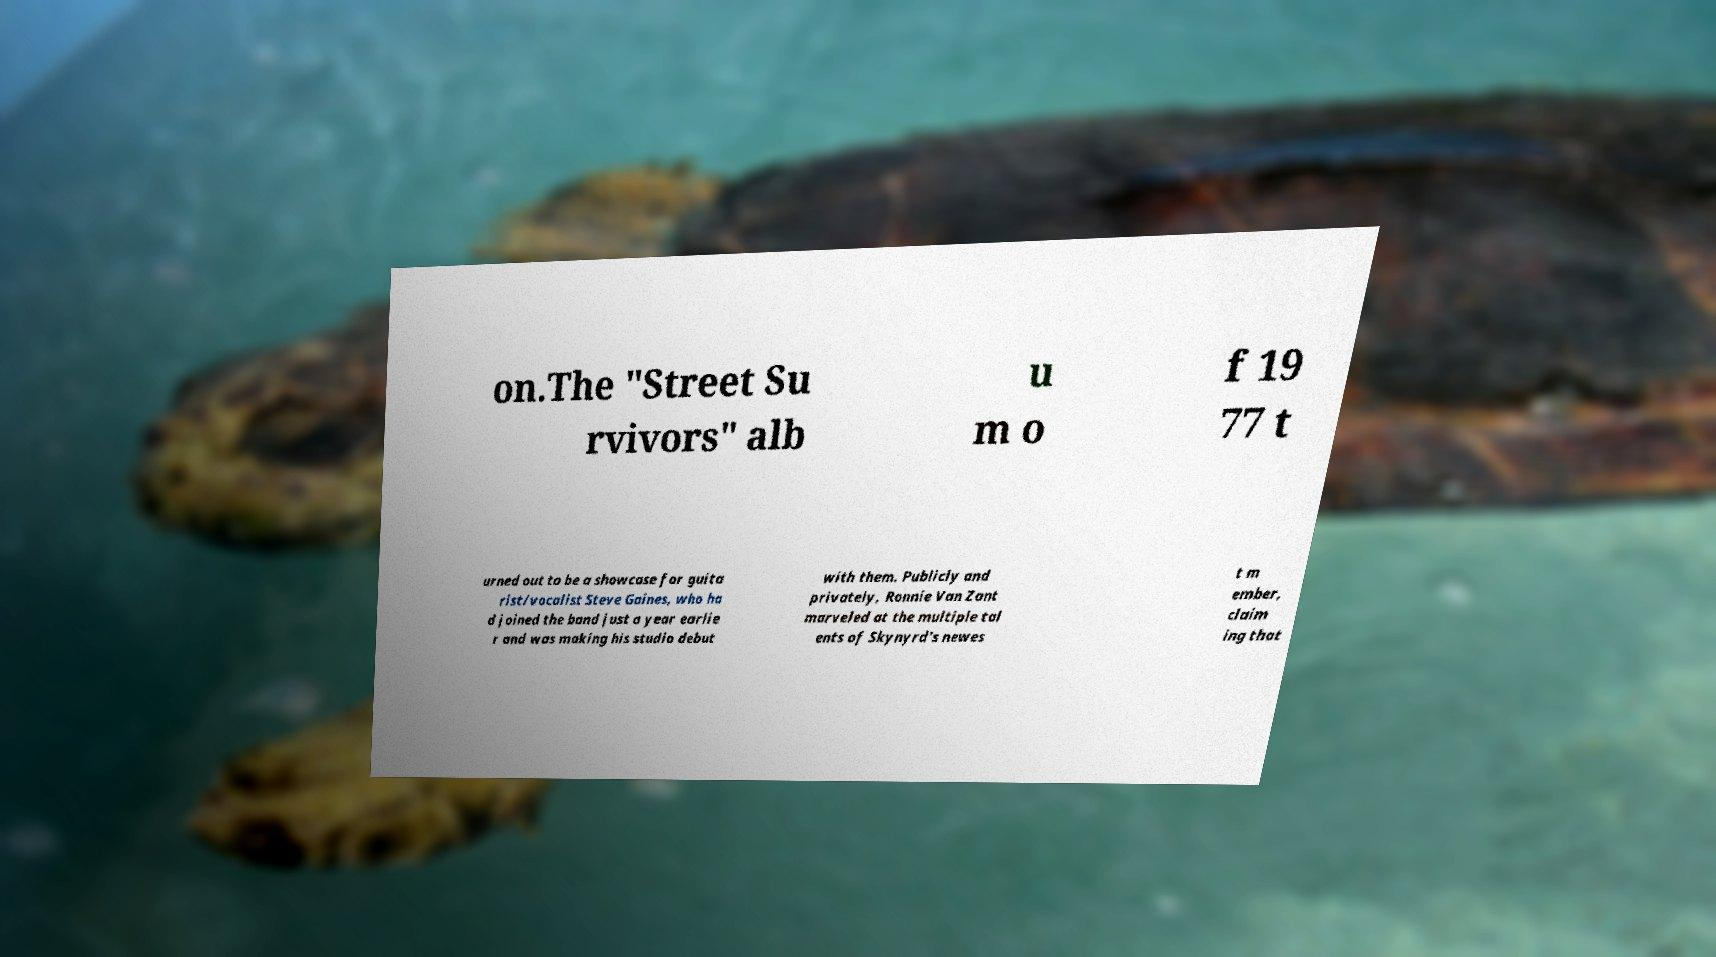There's text embedded in this image that I need extracted. Can you transcribe it verbatim? on.The "Street Su rvivors" alb u m o f 19 77 t urned out to be a showcase for guita rist/vocalist Steve Gaines, who ha d joined the band just a year earlie r and was making his studio debut with them. Publicly and privately, Ronnie Van Zant marveled at the multiple tal ents of Skynyrd's newes t m ember, claim ing that 